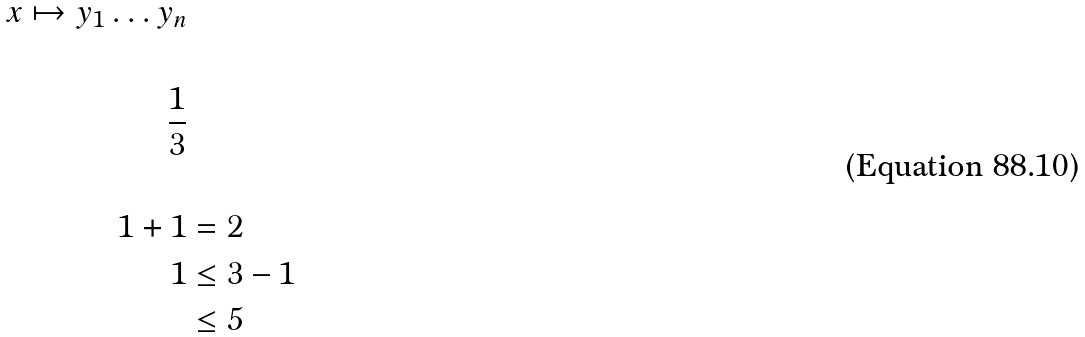Convert formula to latex. <formula><loc_0><loc_0><loc_500><loc_500>x \mapsto y _ { 1 } \dots y _ { n } \\ \\ \frac { 1 } { 3 } \\ \\ 1 + 1 & = 2 \\ 1 & \leq 3 - 1 \\ & \leq 5</formula> 